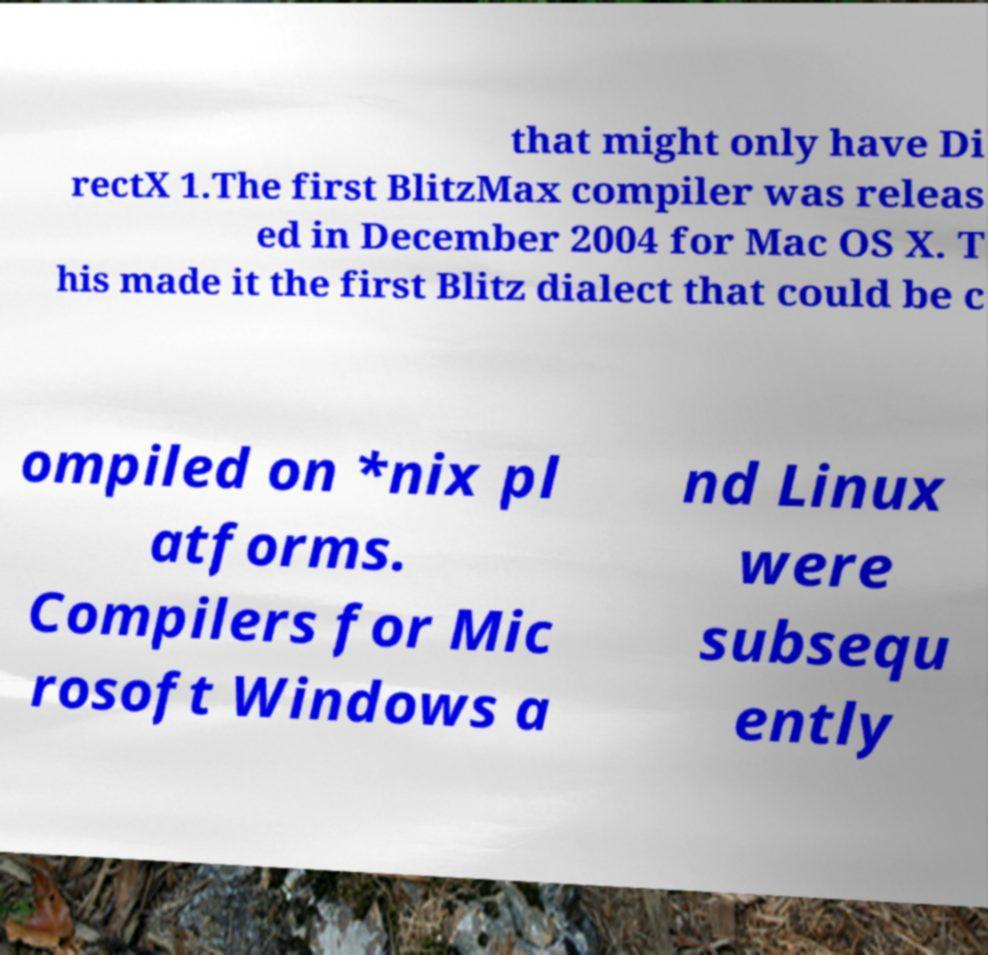Can you accurately transcribe the text from the provided image for me? that might only have Di rectX 1.The first BlitzMax compiler was releas ed in December 2004 for Mac OS X. T his made it the first Blitz dialect that could be c ompiled on *nix pl atforms. Compilers for Mic rosoft Windows a nd Linux were subsequ ently 